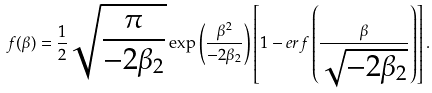Convert formula to latex. <formula><loc_0><loc_0><loc_500><loc_500>f ( \beta ) = \frac { 1 } { 2 } \sqrt { \frac { \pi } { - 2 \beta _ { 2 } } } \exp \left ( { \frac { \beta ^ { 2 } } { - 2 \beta _ { 2 } } } \right ) \left [ { 1 - e r f \left ( { \frac { \beta } { \sqrt { - 2 \beta _ { 2 } } } } \right ) } \right ] .</formula> 